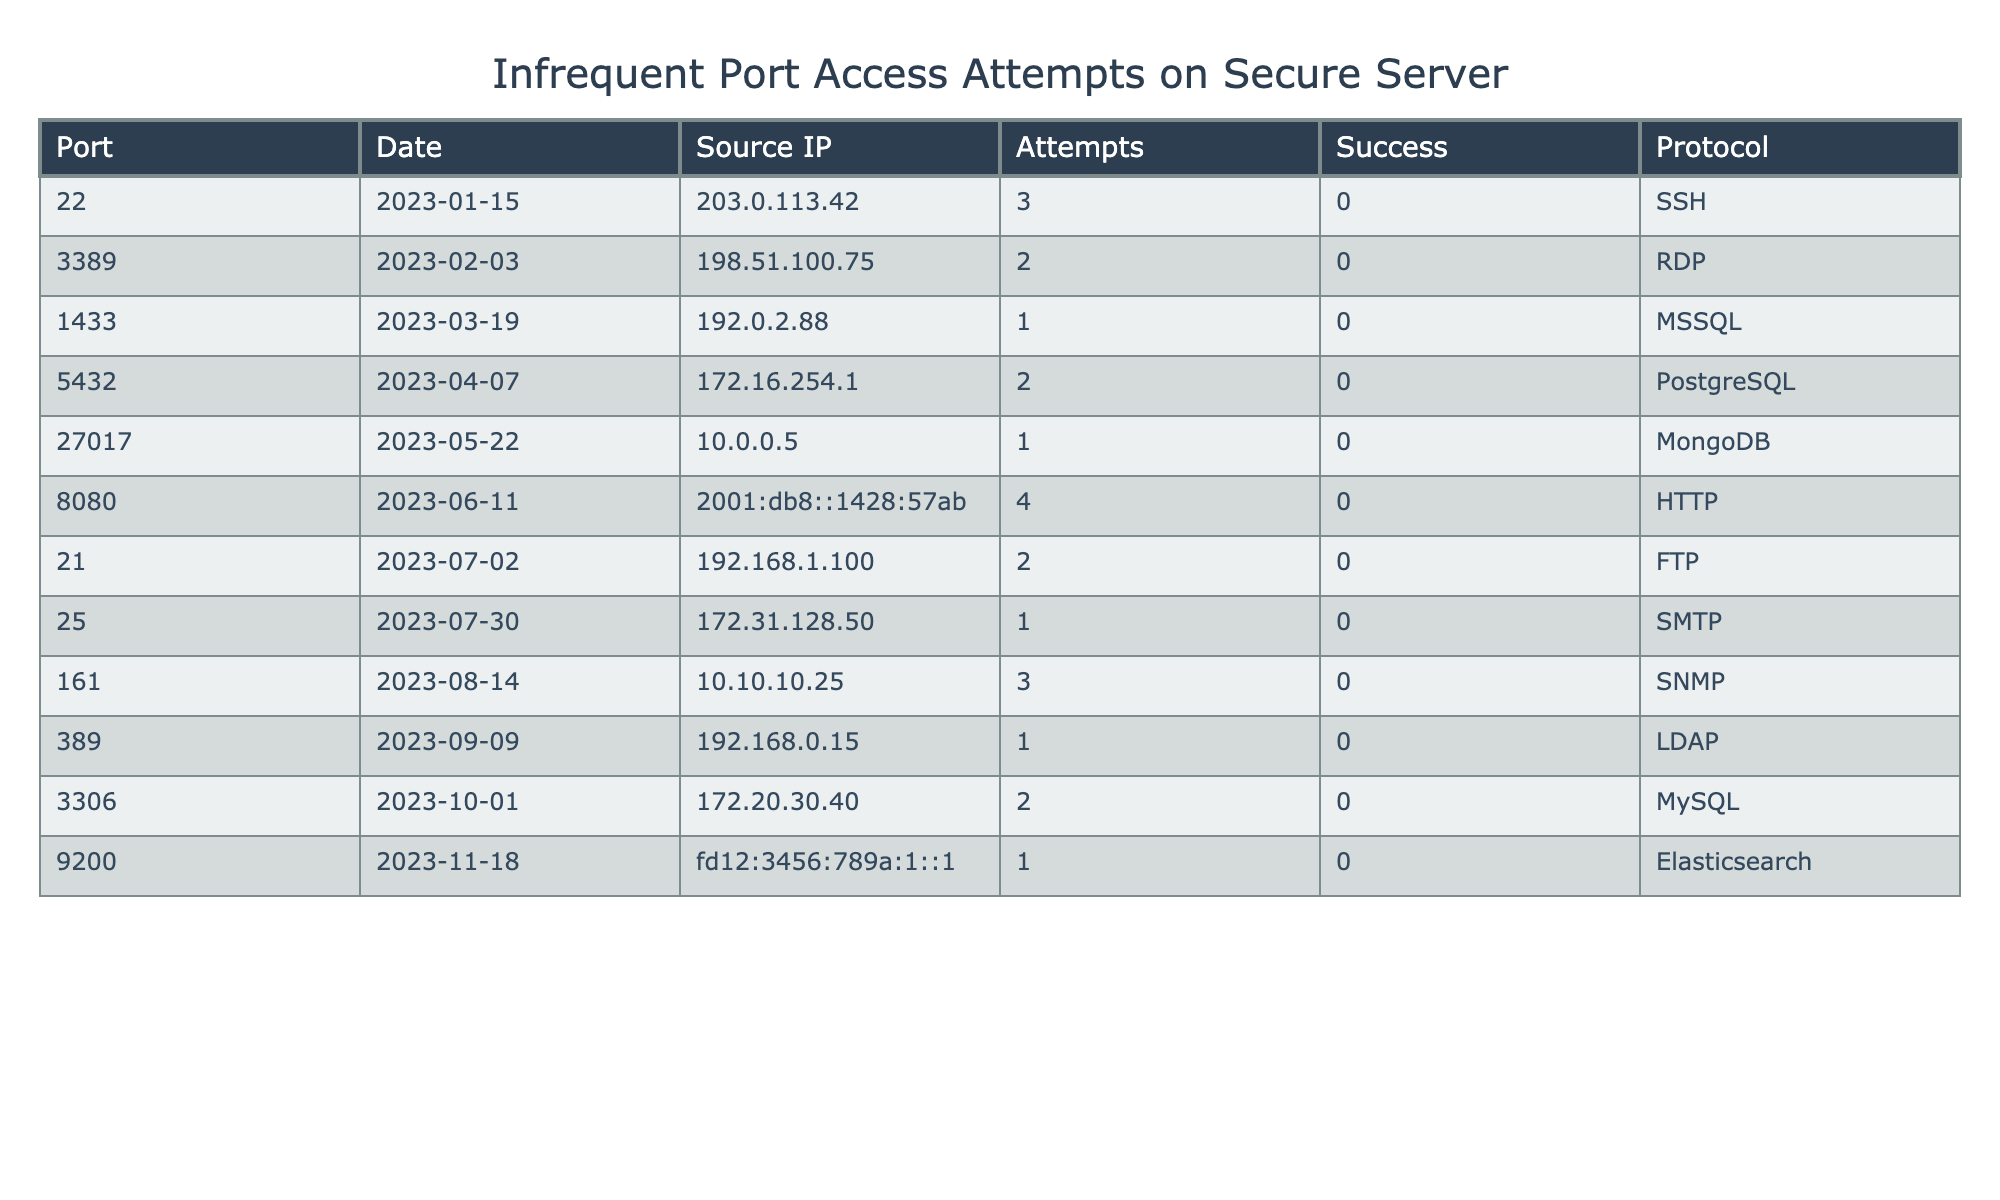What is the total number of access attempts recorded in the table? To find the total number of access attempts, we sum up the values in the "Attempts" column: 3 + 2 + 1 + 2 + 1 + 4 + 2 + 1 + 3 + 1 + 2 + 1 = 23
Answer: 23 Which port had the highest number of access attempts and how many were there? The highest number of access attempts is found by checking each port's attempts. Port 8080 had the highest attempts with a total of 4.
Answer: Port 8080, 4 How many ports had access attempts recorded in the month of July? By reviewing the "Date" column for July entries, there are 2 ports (21 and 25) with recorded attempts in July.
Answer: 2 Did any of the access attempts result in a success? Reviewing the "Success" column shows that all attempts have a value of 0, indicating that none were successful.
Answer: No What is the average number of access attempts per port? To find the average, divide the total number of attempts (23) by the number of unique ports (12). Thus, 23 / 12 = approximately 1.917, which rounds to 2.
Answer: 2 Which protocol recorded the least number of attempts? By checking the "Attempts" column, the protocols with the least attempts (1 each) are MSSQL, MongoDB, and Elasticsearch.
Answer: MSSQL, MongoDB, Elasticsearch How many unique source IP addresses are listed in the data? By counting the unique entries in the "Source IP" column, we find that there are 12 unique source IP addresses.
Answer: 12 Was there more than one access attempt for port 22 over the 6-month period? The "Attempts" column shows that port 22 had 3 attempts recorded, indicating more than one attempt.
Answer: Yes How many different protocols were used in the recorded attempts? By listing the protocols from the "Protocol" column, we find a total of 8 different protocols.
Answer: 8 Which port had a successful access attempt? Reviewing the "Success" column, all entries show 0, indicating no port had a successful attempt.
Answer: None 